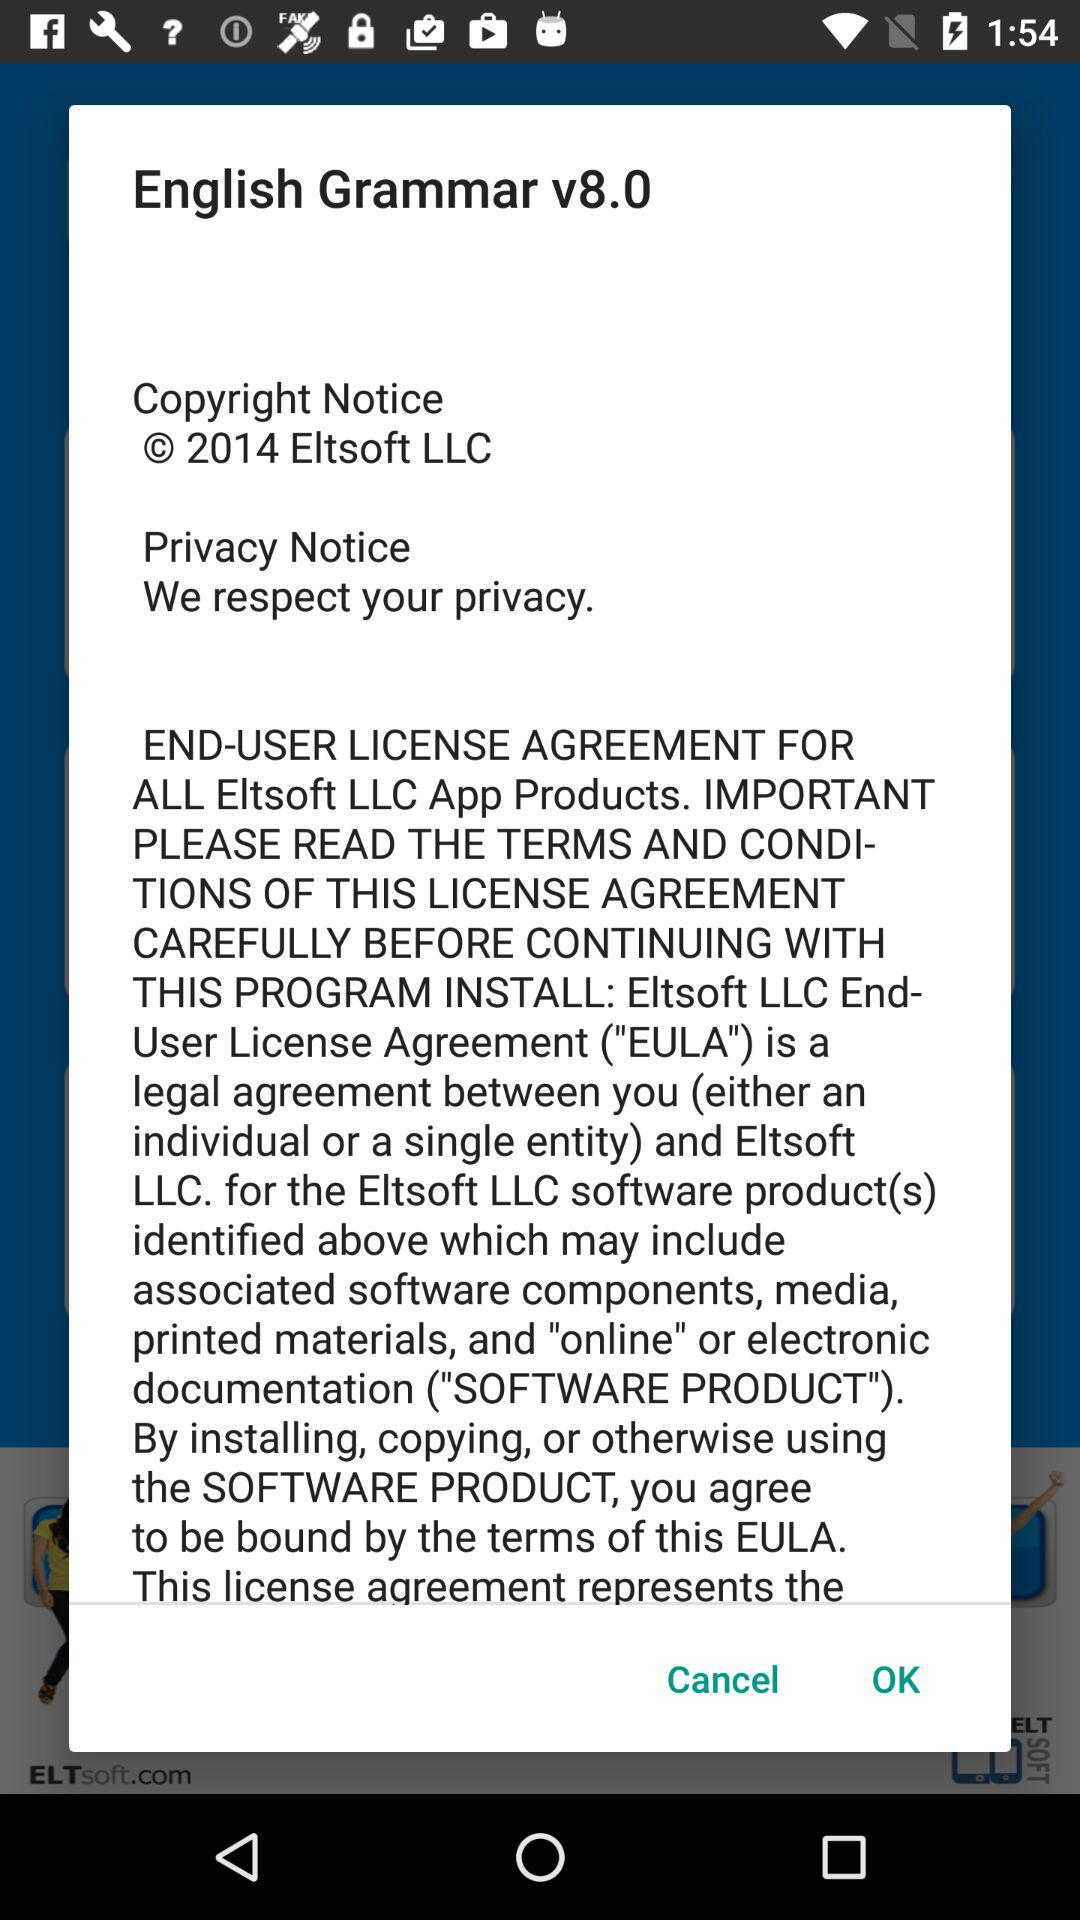What is the name of the application? The name of the application is "English Grammar". 